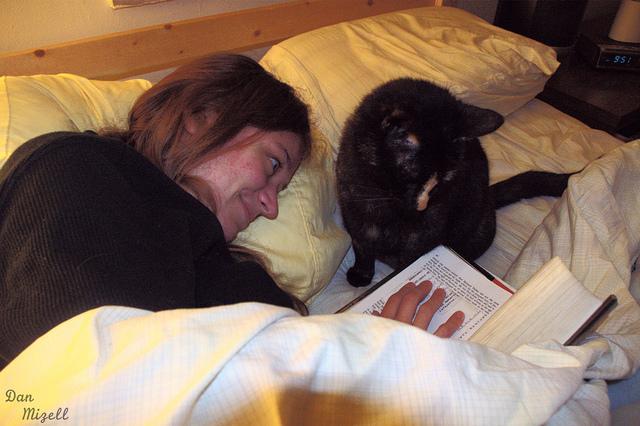What is the woman holding in her hand?
Answer briefly. Book. Is the cat in the suitcase?
Short answer required. No. What time is it?
Be succinct. 9:51. What color is the cat?
Quick response, please. Black. What room are the cat and human in?
Quick response, please. Bedroom. Is the dog small or large?
Answer briefly. Small. What is the girl doing with her hand?
Give a very brief answer. Holding down book. 